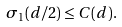Convert formula to latex. <formula><loc_0><loc_0><loc_500><loc_500>\sigma _ { 1 } ( d / 2 ) \leq C ( d ) .</formula> 